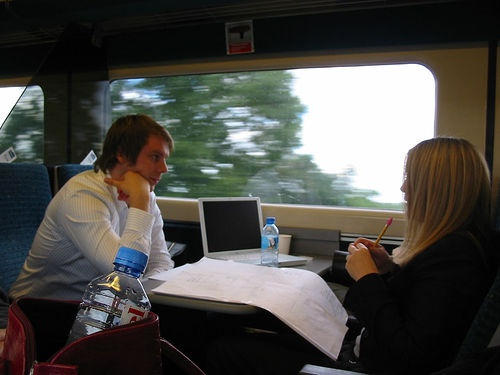Describe the objects in this image and their specific colors. I can see people in black, maroon, and gray tones, people in black, gray, and maroon tones, handbag in black, maroon, gray, and brown tones, chair in black, darkgray, and gray tones, and bottle in black, gray, darkgray, and navy tones in this image. 